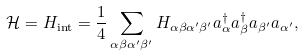<formula> <loc_0><loc_0><loc_500><loc_500>\mathcal { H } = H _ { \text {int} } = \frac { 1 } { 4 } \sum _ { \alpha \beta \alpha ^ { \prime } \beta ^ { \prime } } H _ { \alpha \beta \alpha ^ { \prime } \beta ^ { \prime } } a _ { \alpha } ^ { \dagger } a _ { \beta } ^ { \dagger } a _ { \beta ^ { \prime } } a _ { \alpha ^ { \prime } } ,</formula> 